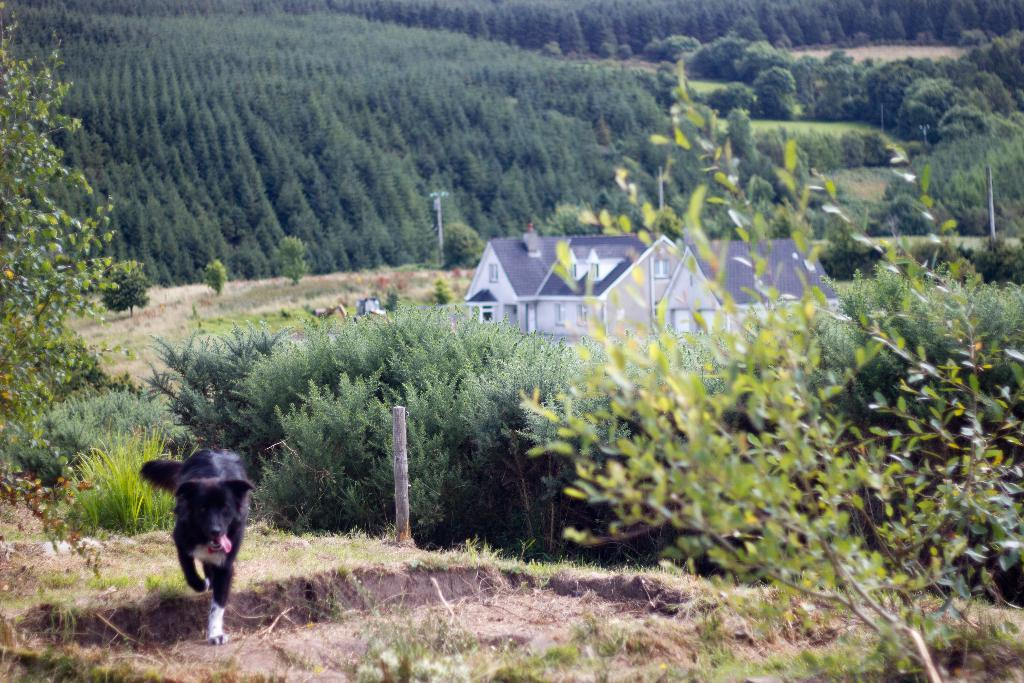What animal is on the ground in the image? There is a dog on the ground in the image. What type of vegetation can be seen in the image? There are trees, grass, and plants in the image. What structures are present in the image? There are poles and houses in the image. image. How many beds can be seen in the image? There are no beds present in the image. Is there a man operating a plough in the image? There is no man or plough present in the image. 